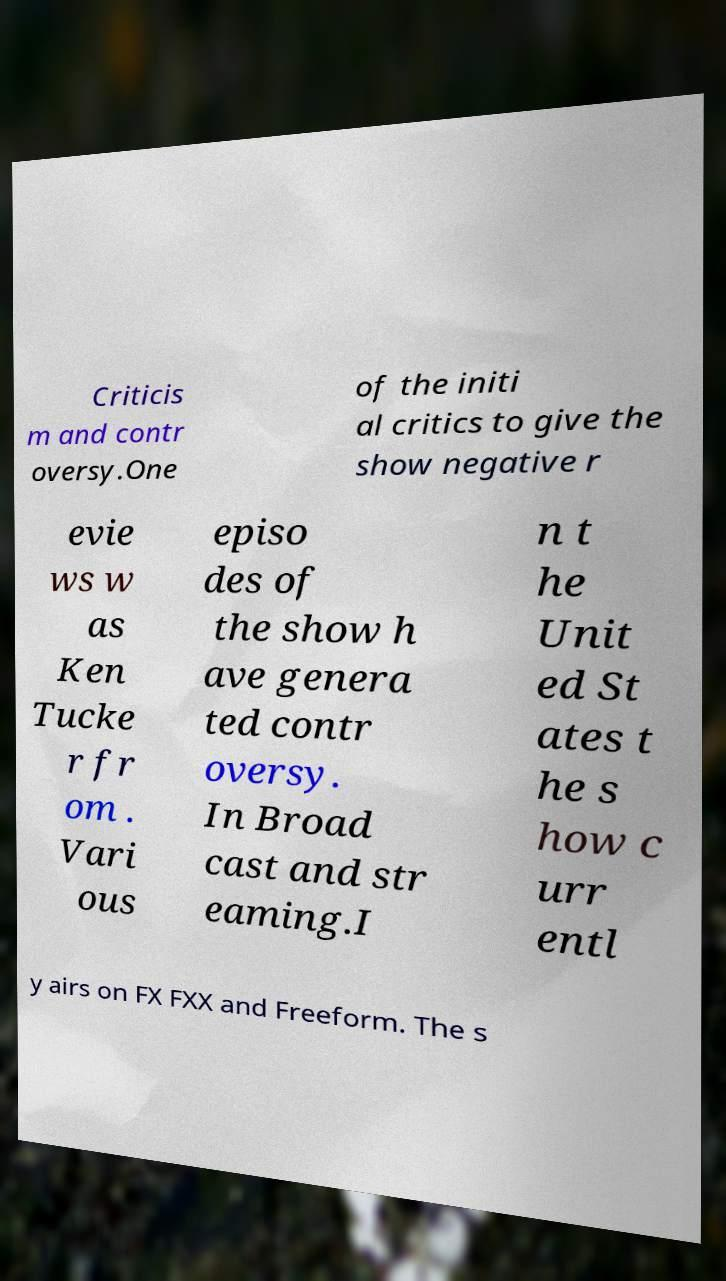There's text embedded in this image that I need extracted. Can you transcribe it verbatim? Criticis m and contr oversy.One of the initi al critics to give the show negative r evie ws w as Ken Tucke r fr om . Vari ous episo des of the show h ave genera ted contr oversy. In Broad cast and str eaming.I n t he Unit ed St ates t he s how c urr entl y airs on FX FXX and Freeform. The s 